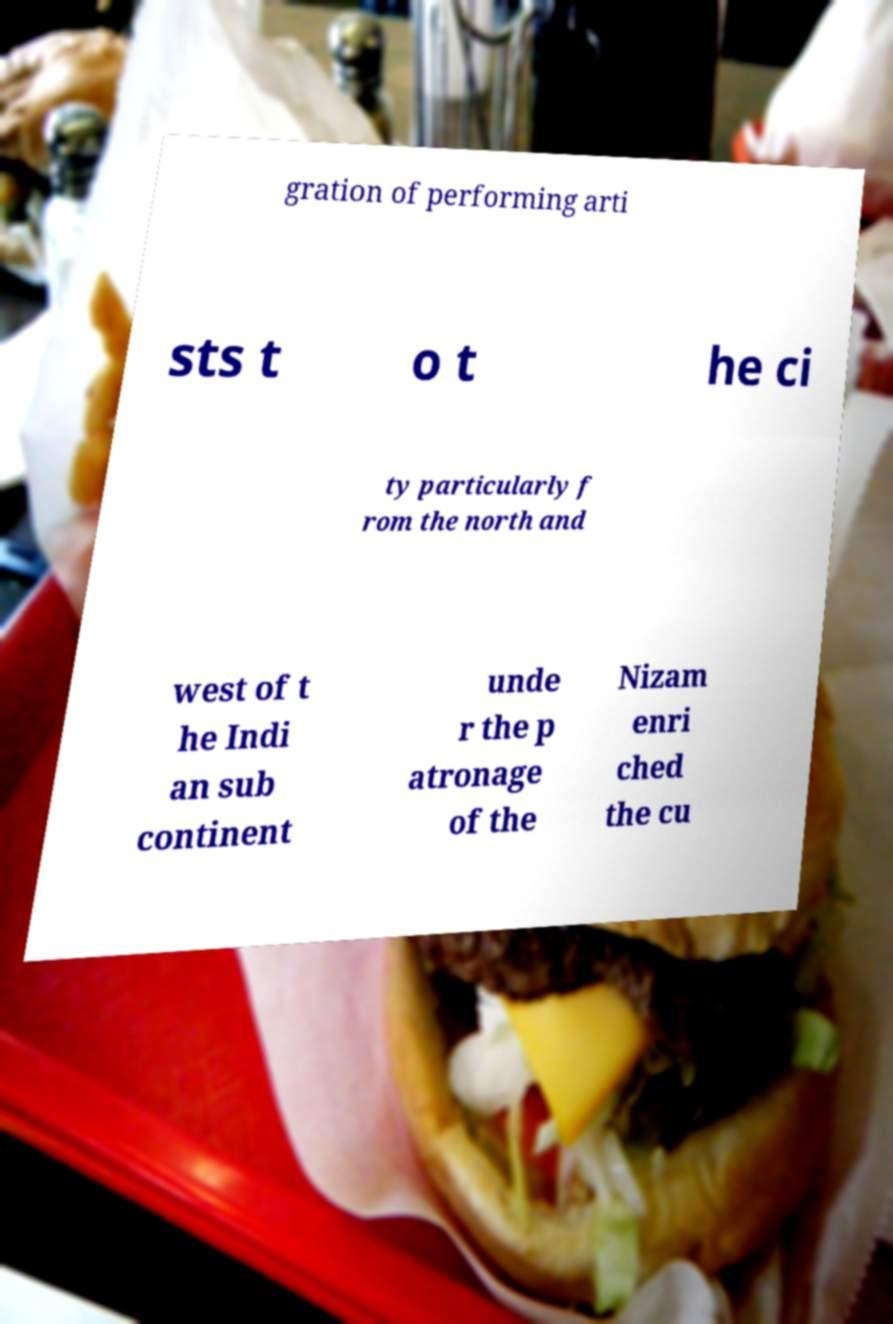Could you assist in decoding the text presented in this image and type it out clearly? gration of performing arti sts t o t he ci ty particularly f rom the north and west of t he Indi an sub continent unde r the p atronage of the Nizam enri ched the cu 